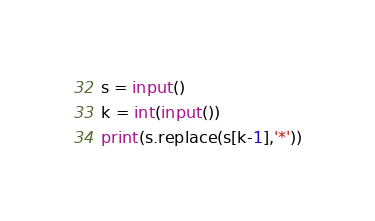Convert code to text. <code><loc_0><loc_0><loc_500><loc_500><_Python_>s = input()
k = int(input())
print(s.replace(s[k-1],'*'))

</code> 